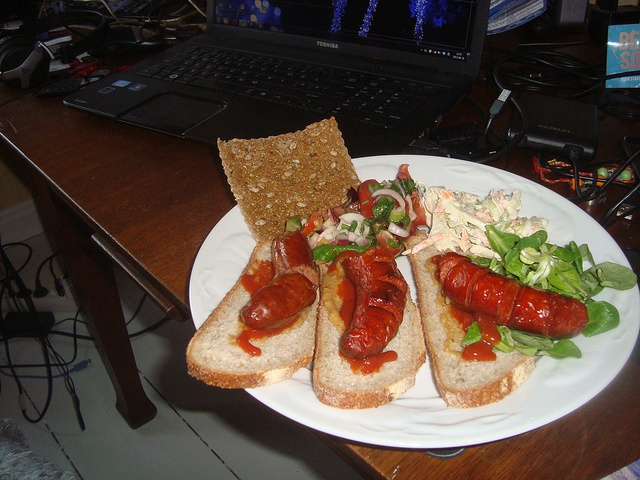Describe the objects in this image and their specific colors. I can see dining table in black, lightgray, maroon, and brown tones, laptop in black, navy, gray, and darkblue tones, hot dog in black, brown, tan, and maroon tones, sandwich in black, maroon, tan, and brown tones, and hot dog in black, maroon, tan, and brown tones in this image. 